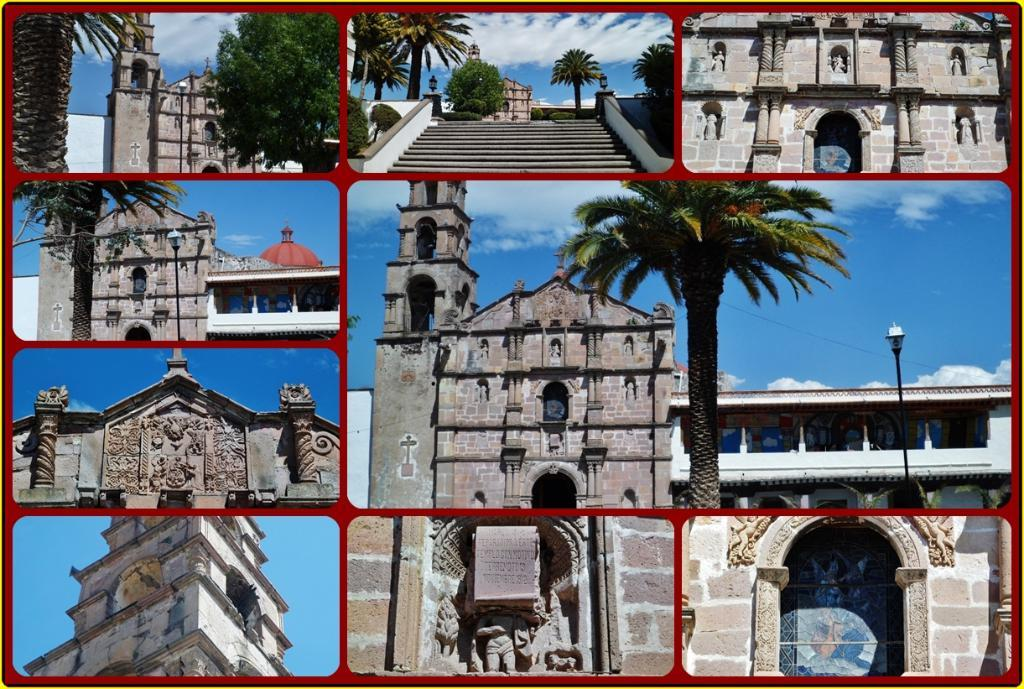What type of artwork is the image? The image is a collage. What structures can be seen in the collage? There are buildings in the image. What type of vegetation is present in the collage? There are trees in the image. What architectural feature is visible in the collage? There are stairs in the image. What type of sculptures are in the collage? There are statues in the image. What type of street furniture is present in the collage? There is a light pole in the image. What type of weather can be inferred from the image? There are clouds in the image, which suggests a partly cloudy day. What part of the natural environment is visible in the image? The sky is visible in the image. What type of eggs are being used to cover the statues in the image? There are no eggs present in the image, and the statues are not being covered. 